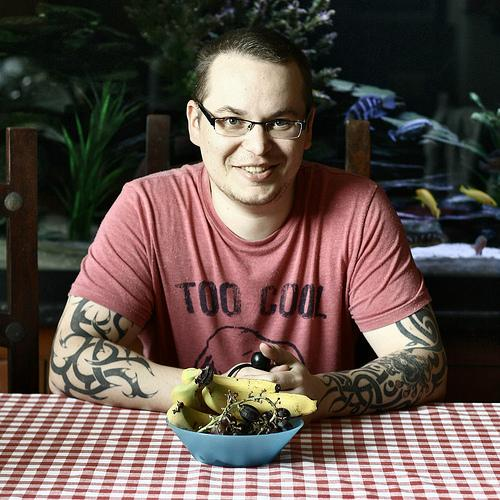What sort of diet might the person at the table have? Please explain your reasoning. vegan. The bowl in front of the person is not empty, so he is not fasting. the bowl has bananas and grapes, not meat. 